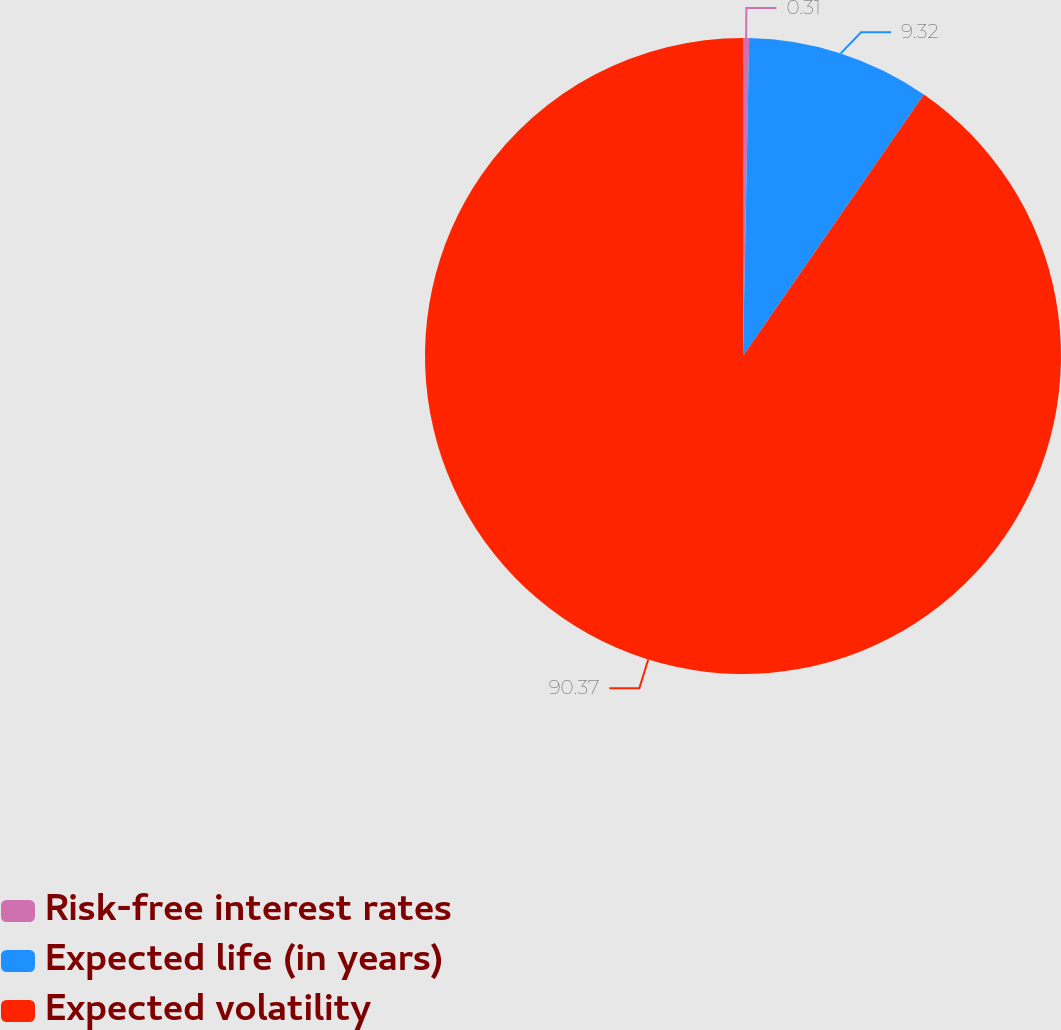Convert chart to OTSL. <chart><loc_0><loc_0><loc_500><loc_500><pie_chart><fcel>Risk-free interest rates<fcel>Expected life (in years)<fcel>Expected volatility<nl><fcel>0.31%<fcel>9.32%<fcel>90.37%<nl></chart> 